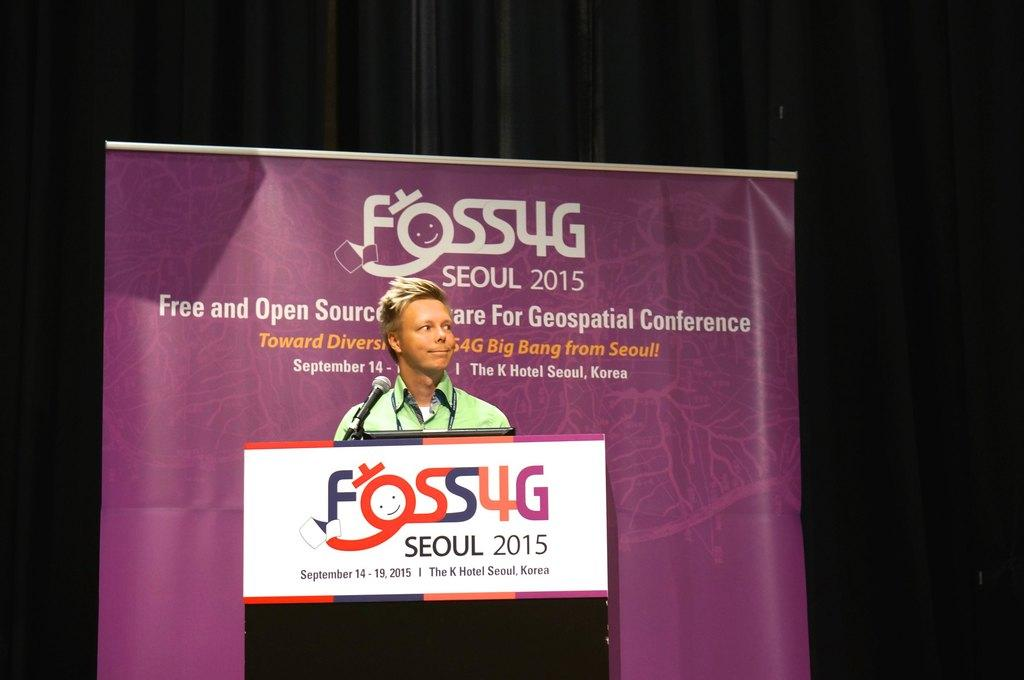What is the person on the dais doing? The person is standing on a dais and holding a microphone. What might the person be using the microphone for? The person might be using the microphone for speaking or singing. What can be seen behind the person on the dais? There is a banner behind the person. How many records can be seen on the dais in the image? There are no records visible in the image; only a person, a microphone, and a banner are present. 